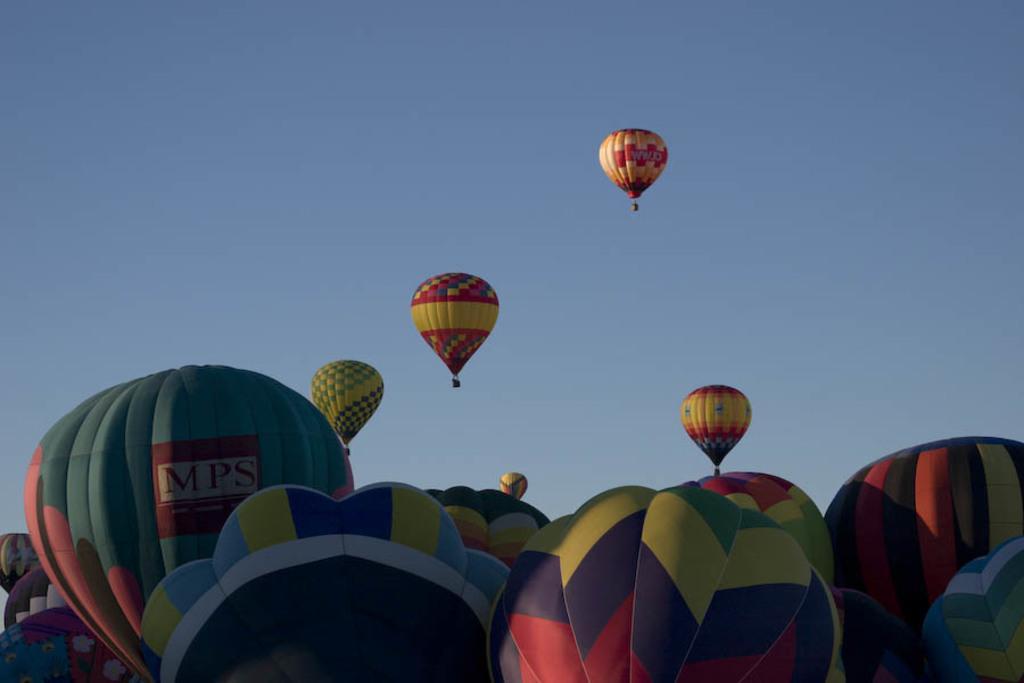Can you describe this image briefly? In this image we can see some hot air balloons in the air. Sky is also visible. 